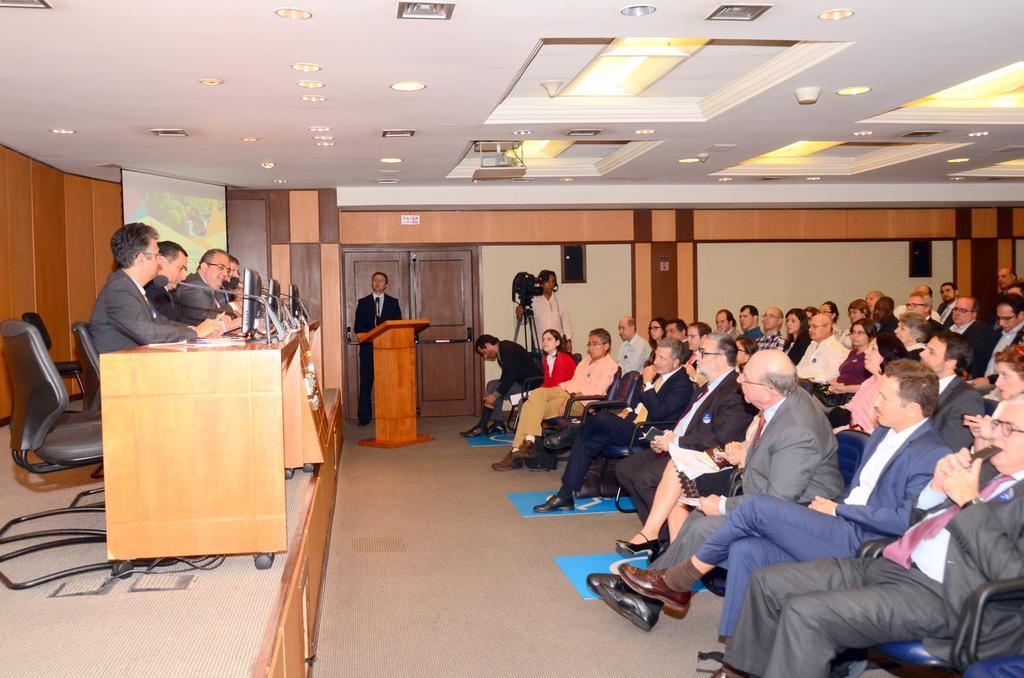Can you describe this image briefly? There are group of people sitting in chairs and there is a table in front of them which has desktops and mic in front of them and there are group of people sitting in chairs in the right corner in front of them and there is a camera and a person standing in front of a wooden table in the background. 